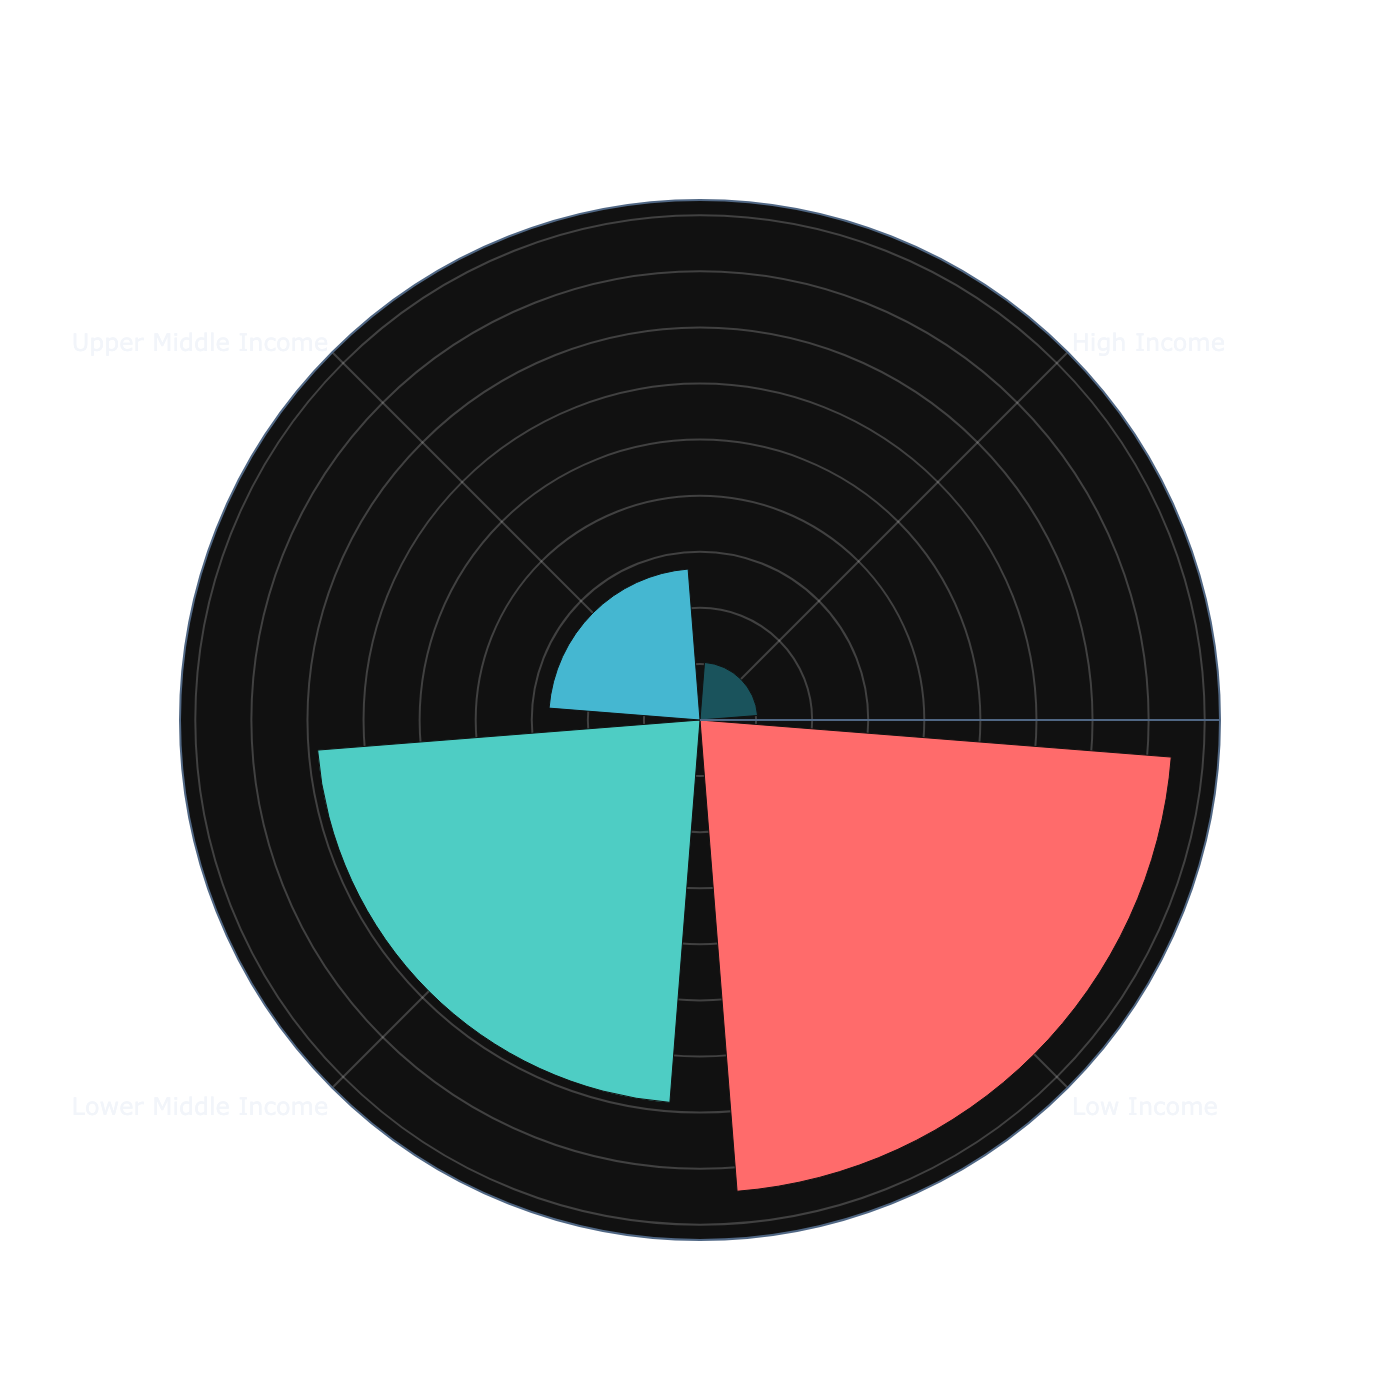what is the title of the chart? The title can be found at the top of the chart.
Answer: Child Mortality Rates by Income Group how many income groups are represented in the chart? The number of distinct sections in the rose chart indicates the number of income groups.
Answer: 4 which income group has the highest child mortality rate? Locate the section with the longest radius; this represents the income group with the highest child mortality rate.
Answer: Low Income which income group has the lowest child mortality rate? Find the section with the shortest radius; this represents the income group with the lowest child mortality rate.
Answer: High Income what is the child mortality rate for the 'Upper Middle Income' group? Check the annotation within the section labeled 'Upper Middle Income'.
Answer: 13.5 what is the difference in child mortality rates between 'Low Income' and 'High Income' groups? Subtract the child mortality rate of 'High Income' from that of 'Low Income'.
Answer: 38.1 how does the 'Lower Middle Income' group's child mortality rate compare to the 'Upper Middle Income' group? Compare the length of the respective sections and their annotated values.
Answer: Lower Middle Income is higher what is the average child mortality rate across all income groups? Sum the child mortality rates and divide by the number of groups: (45.6+34.1+13.5+5.1)/4
Answer: 24.6 what can you infer about the relationship between income level and child mortality rate in this chart? Observing the trend where sections with higher income levels have shorter radii suggests that child mortality rates tend to decrease with higher income levels.
Answer: Decreases with higher income levels 